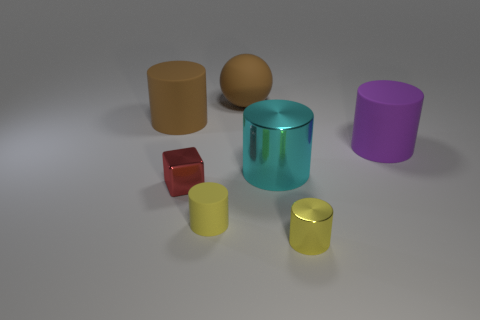Add 1 small blocks. How many objects exist? 8 Subtract all blocks. How many objects are left? 6 Subtract 0 gray balls. How many objects are left? 7 Subtract all yellow cylinders. Subtract all small yellow objects. How many objects are left? 3 Add 2 cylinders. How many cylinders are left? 7 Add 4 gray shiny cubes. How many gray shiny cubes exist? 4 